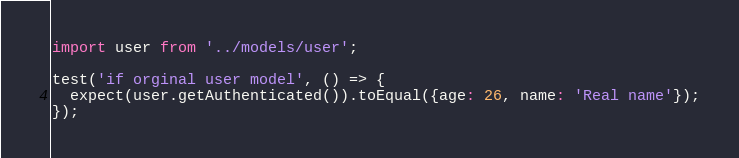<code> <loc_0><loc_0><loc_500><loc_500><_JavaScript_>import user from '../models/user';

test('if orginal user model', () => {
  expect(user.getAuthenticated()).toEqual({age: 26, name: 'Real name'});
});
</code> 